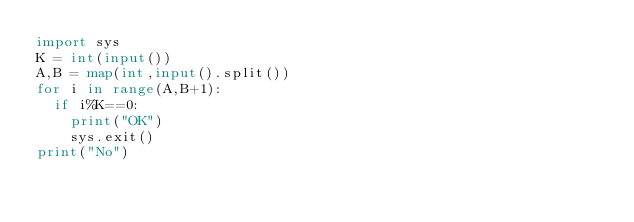Convert code to text. <code><loc_0><loc_0><loc_500><loc_500><_Python_>import sys
K = int(input())
A,B = map(int,input().split())
for i in range(A,B+1):
  if i%K==0:
    print("OK")
    sys.exit()
print("No")</code> 